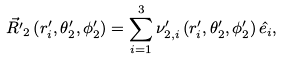Convert formula to latex. <formula><loc_0><loc_0><loc_500><loc_500>\vec { R ^ { \prime } } _ { 2 } \left ( r ^ { \prime } _ { i } , \theta ^ { \prime } _ { 2 } , \phi ^ { \prime } _ { 2 } \right ) & = \sum _ { i = 1 } ^ { 3 } \nu ^ { \prime } _ { 2 , i } \left ( r ^ { \prime } _ { i } , \theta ^ { \prime } _ { 2 } , \phi ^ { \prime } _ { 2 } \right ) \hat { e _ { i } } ,</formula> 